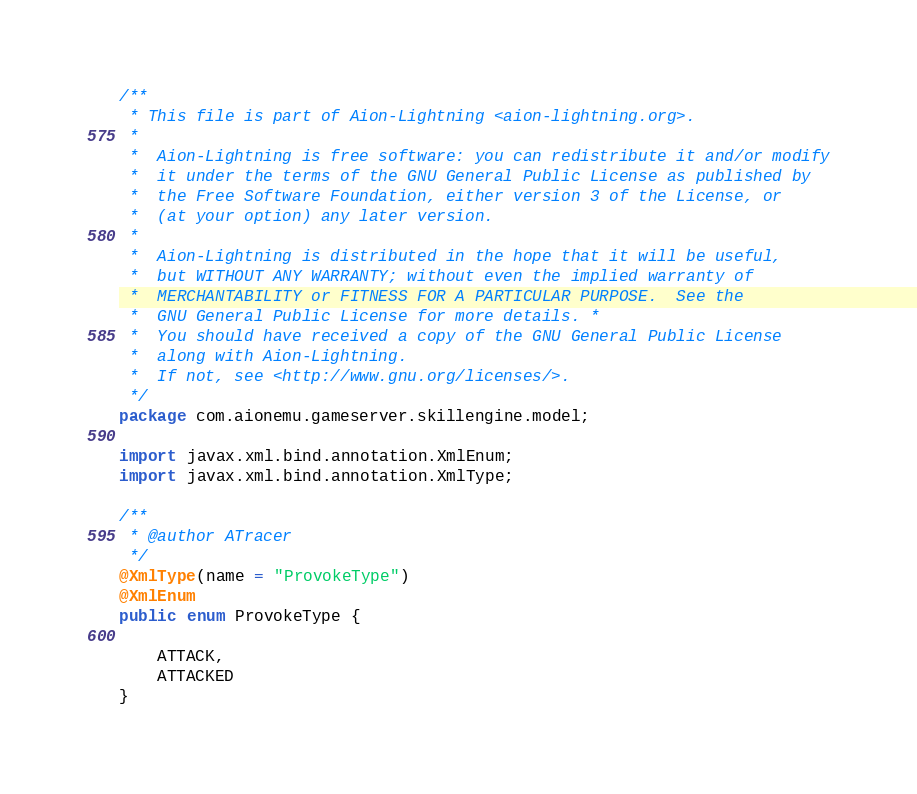Convert code to text. <code><loc_0><loc_0><loc_500><loc_500><_Java_>/**
 * This file is part of Aion-Lightning <aion-lightning.org>.
 *
 *  Aion-Lightning is free software: you can redistribute it and/or modify
 *  it under the terms of the GNU General Public License as published by
 *  the Free Software Foundation, either version 3 of the License, or
 *  (at your option) any later version.
 *
 *  Aion-Lightning is distributed in the hope that it will be useful,
 *  but WITHOUT ANY WARRANTY; without even the implied warranty of
 *  MERCHANTABILITY or FITNESS FOR A PARTICULAR PURPOSE.  See the
 *  GNU General Public License for more details. *
 *  You should have received a copy of the GNU General Public License
 *  along with Aion-Lightning.
 *  If not, see <http://www.gnu.org/licenses/>.
 */
package com.aionemu.gameserver.skillengine.model;

import javax.xml.bind.annotation.XmlEnum;
import javax.xml.bind.annotation.XmlType;

/**
 * @author ATracer
 */
@XmlType(name = "ProvokeType")
@XmlEnum
public enum ProvokeType {

    ATTACK,
    ATTACKED
}
</code> 